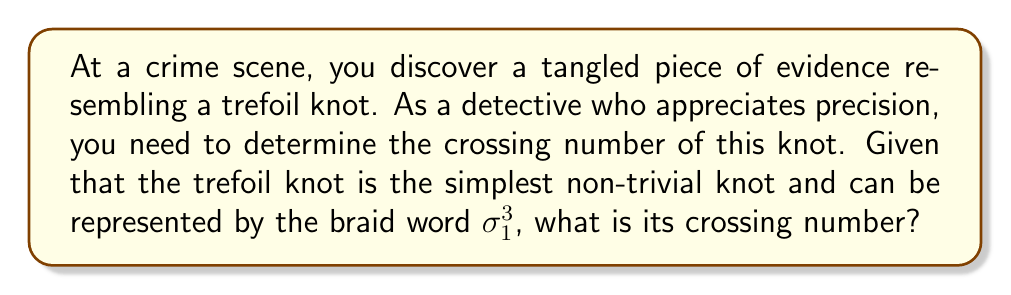Provide a solution to this math problem. To determine the crossing number of the trefoil knot, we'll follow these steps:

1. Understand the braid representation:
   The trefoil knot is represented by the braid word $\sigma_1^3$, which means three consecutive positive crossings of the first strand over the second.

2. Visualize the knot:
   [asy]
   import geometry;
   
   size(100);
   
   path p = (0,0)..(1,1)..(2,0)..(1,-1)..cycle;
   draw(p, black+1);
   draw(p, white+3);
   draw(p, black+1);
   
   label("1", (0.5,0.5), NE);
   label("2", (1.5,0.5), NW);
   label("3", (1,-0.5), S);
   [/asy]

3. Count the crossings:
   In the minimal diagram of a trefoil knot, we can clearly see 3 crossings.

4. Prove minimality:
   The trefoil knot is known to be a prime knot, meaning it cannot be decomposed into simpler knots. It's also known to be non-trivial (not isotopic to the unknot). The simplest non-trivial prime knots have a crossing number of 3.

5. Verify with the braid word:
   The braid word $\sigma_1^3$ indicates 3 crossings, which matches our visual count.

Therefore, the crossing number of the trefoil knot is 3.
Answer: 3 